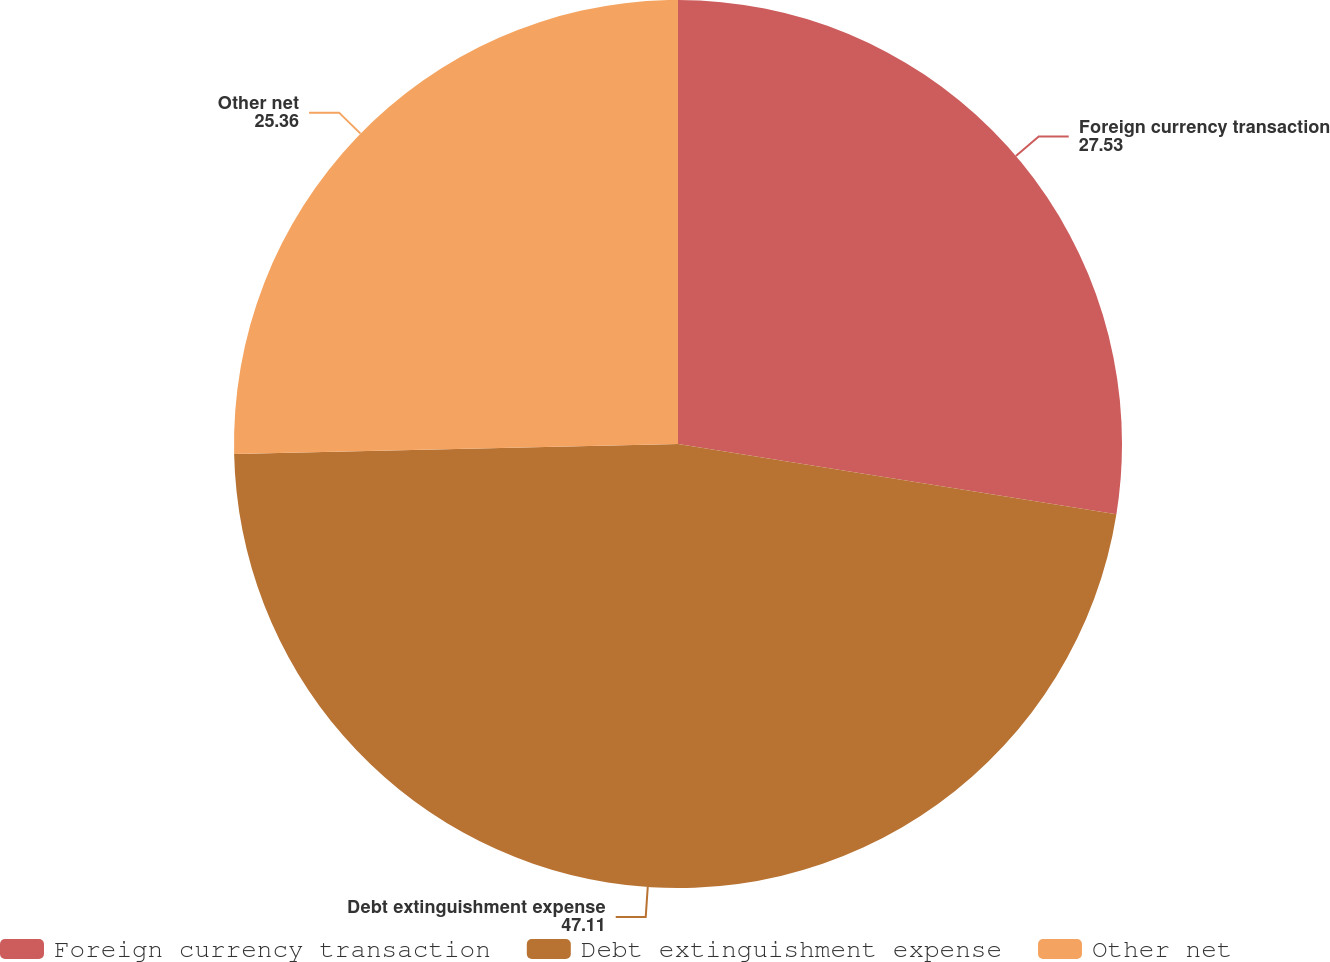Convert chart. <chart><loc_0><loc_0><loc_500><loc_500><pie_chart><fcel>Foreign currency transaction<fcel>Debt extinguishment expense<fcel>Other net<nl><fcel>27.53%<fcel>47.11%<fcel>25.36%<nl></chart> 